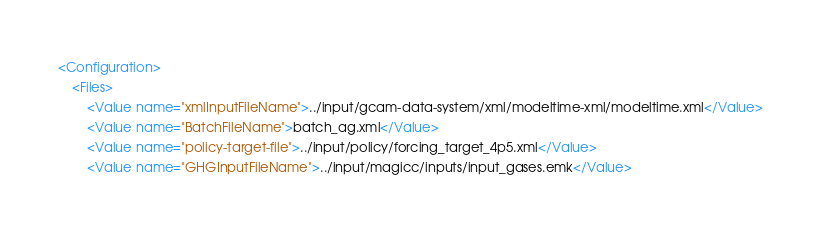Convert code to text. <code><loc_0><loc_0><loc_500><loc_500><_XML_><Configuration>
	<Files>
		<Value name="xmlInputFileName">../input/gcam-data-system/xml/modeltime-xml/modeltime.xml</Value>
		<Value name="BatchFileName">batch_ag.xml</Value>
		<Value name="policy-target-file">../input/policy/forcing_target_4p5.xml</Value>
		<Value name="GHGInputFileName">../input/magicc/inputs/input_gases.emk</Value></code> 